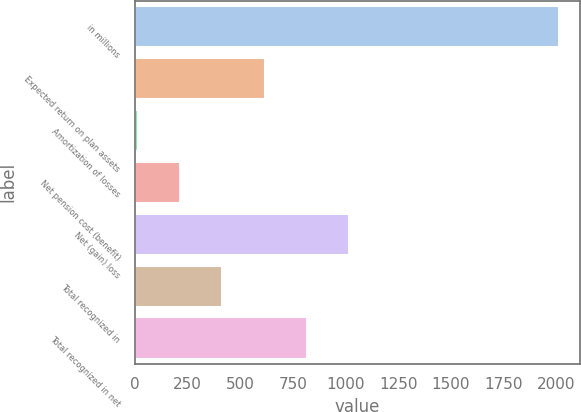Convert chart. <chart><loc_0><loc_0><loc_500><loc_500><bar_chart><fcel>in millions<fcel>Expected return on plan assets<fcel>Amortization of losses<fcel>Net pension cost (benefit)<fcel>Net (gain) loss<fcel>Total recognized in<fcel>Total recognized in net<nl><fcel>2014<fcel>615.4<fcel>16<fcel>215.8<fcel>1015<fcel>415.6<fcel>815.2<nl></chart> 